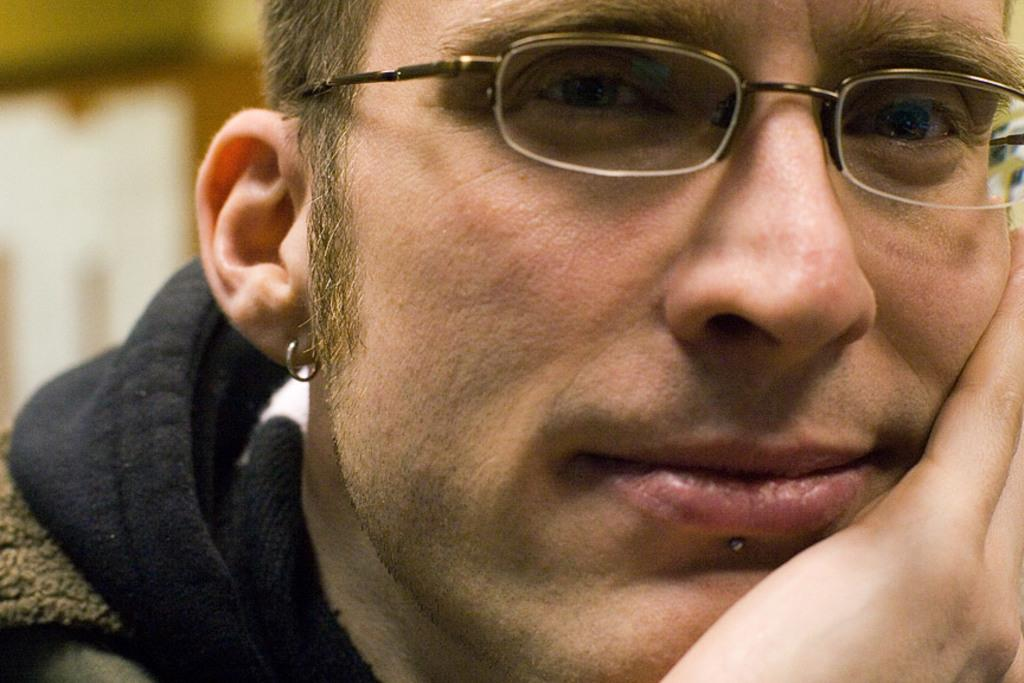Who or what is the main subject of the image? There is a person in the image. Can you describe the person's appearance? The person is wearing spectacles and an earring. What can be seen on the left side of the image? There is a blurred background on the left side of the image. How many mice are visible on the person's shoulder in the image? There are no mice visible on the person's shoulder in the image. What type of health advice can be given to the person based on the image? The image does not provide any information about the person's health, so it is not possible to give health advice based on the image. 